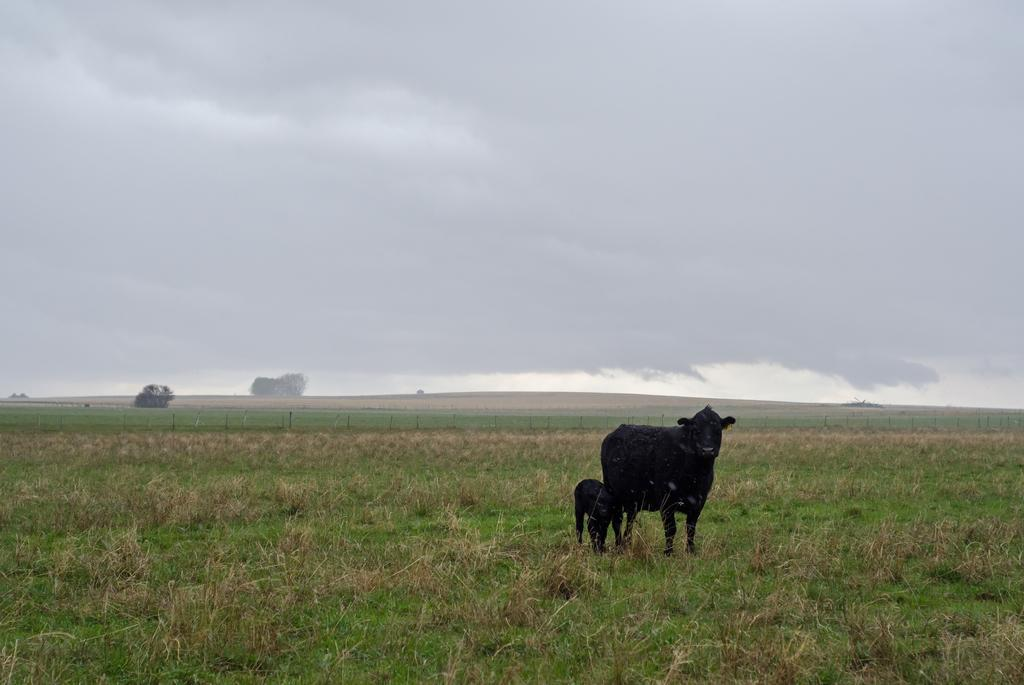How many animals are in the image? There are two animals in the image. What is the surface the animals are standing on? The animals are standing on the grass. What is the barrier in the image? There is a fence in the image. What type of vegetation can be seen in the image? There are trees in the image. What is visible in the background of the image? The sky is visible in the background of the image. What can be observed in the sky? Clouds are present in the sky. What type of songs are the animals singing in the image? There is no indication in the image that the animals are singing songs, so it cannot be determined from the picture. 